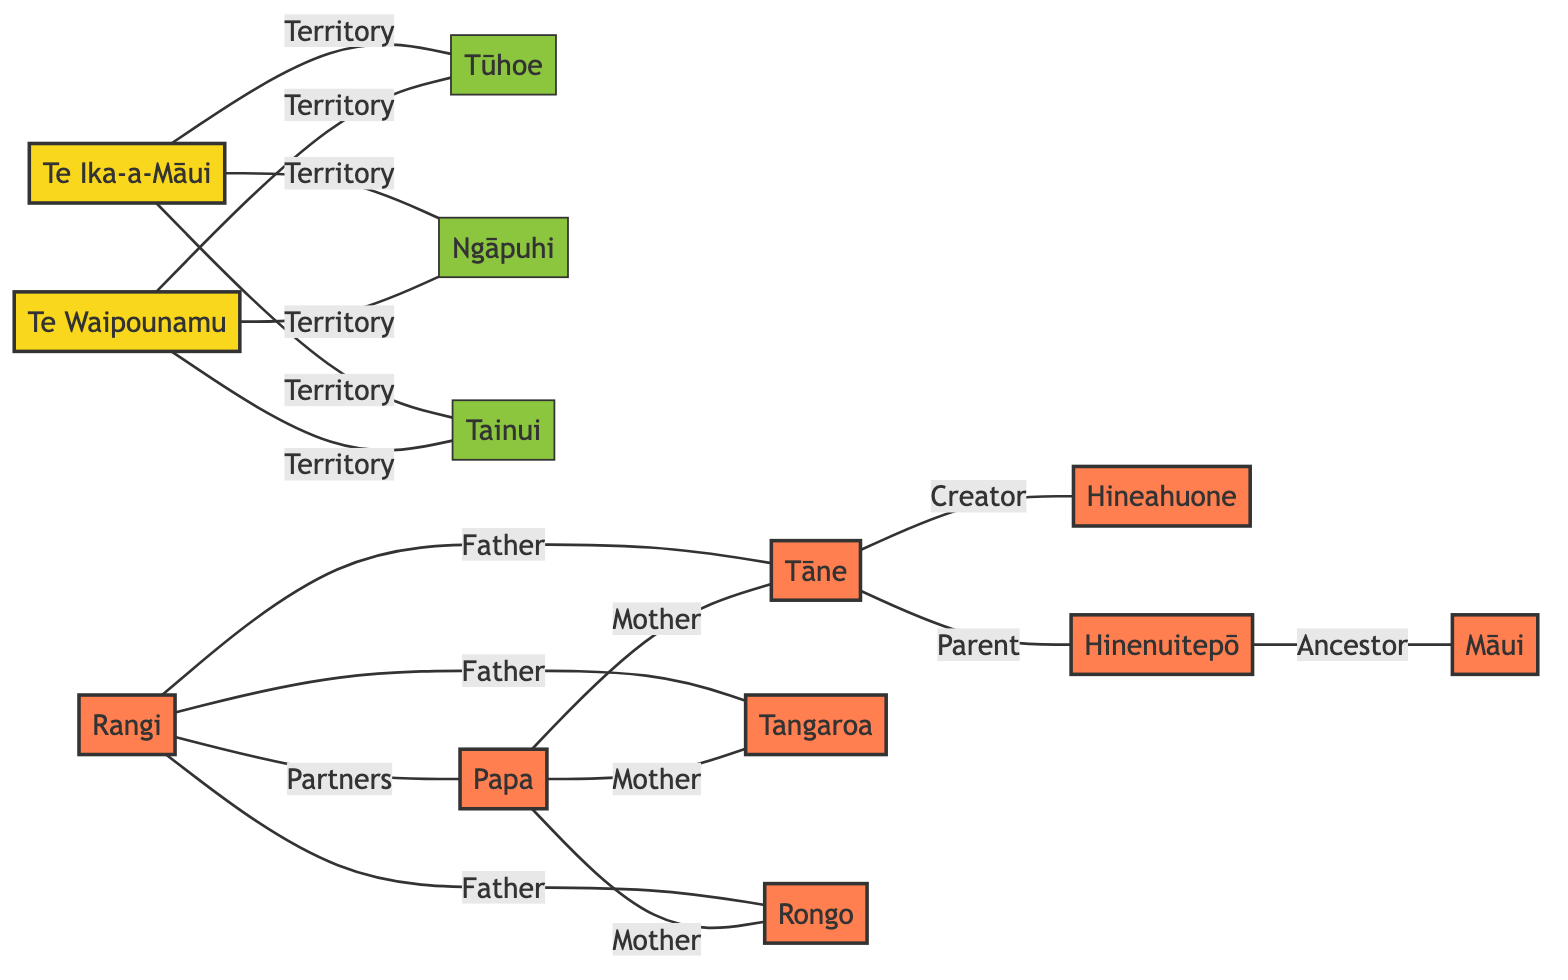What's the total number of nodes in the graph? To find the total number of nodes, count the unique entries in the "nodes" section of the data. There are 13 distinct nodes listed.
Answer: 13 How many edges connect the node Tāne to other nodes? Count the number of edges where Tāne (node 8) is mentioned either as "from" or "to." There are three edges connected to Tāne: Father to Hineahuone, Mother to Hineahuone, and Father to Tangaroa.
Answer: 3 What relationship does Rangi have with Papa? Look for the edge connecting Rangi (node 6) and Papa (node 7). The edge is labeled "Partners."
Answer: Partners How many nodes are classified as 'godNode'? Review the nodes and identify which ones are marked as 'godNode.' There are 8 nodes that fit this classification: Rangi, Papa, Tāne, Tangaroa, Rongo, Māui, Hineahuone, and Hinenuitepō.
Answer: 8 What is the territory connection of Te Ika-a-Māui? Find all edges connected to Te Ika-a-Māui (node 1). It connects to Tūhoe, Ngāpuhi, and Tainui, each labeled "Territory."
Answer: Tūhoe, Ngāpuhi, Tainui Which node is identified as an ancestor of Māui? Look for edges that involve Māui (node 11) as a "child." The edge leading to Māui is connected through Hinenuitepō (node 13), which is marked as "Ancestor."
Answer: Hinenuitepō Which two nodes are connected by the label 'Mother'? Identify edges labeled 'Mother'. The relevant edges are from Papa (node 7) to Tāne (node 8), Tangaroa (node 9), and Rongo (node 10). The connection is to all three nodes from the same parent node.
Answer: Tāne, Tangaroa, Rongo How many distinct relationships are shown in the graph? Count all unique relationship labels in the edges section of the data. The unique relationships are Partners, Father, Mother, Creator, Parent, Ancestor, and Territory, totaling 7 distinct relationships.
Answer: 7 